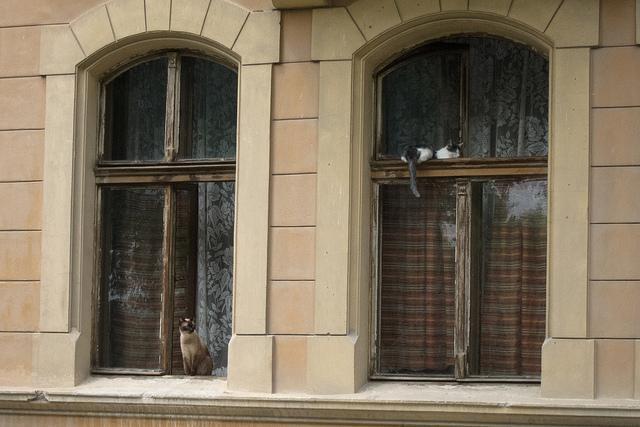How many windows are shown?
Give a very brief answer. 2. How many plates of glass are depicted?
Give a very brief answer. 8. 